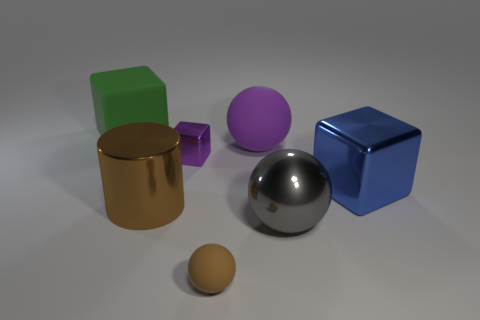Subtract all cyan cylinders. Subtract all red blocks. How many cylinders are left? 1 Add 1 tiny red cylinders. How many objects exist? 8 Subtract all cylinders. How many objects are left? 6 Add 3 large things. How many large things are left? 8 Add 1 shiny cylinders. How many shiny cylinders exist? 2 Subtract 0 blue balls. How many objects are left? 7 Subtract all rubber objects. Subtract all large gray matte cylinders. How many objects are left? 4 